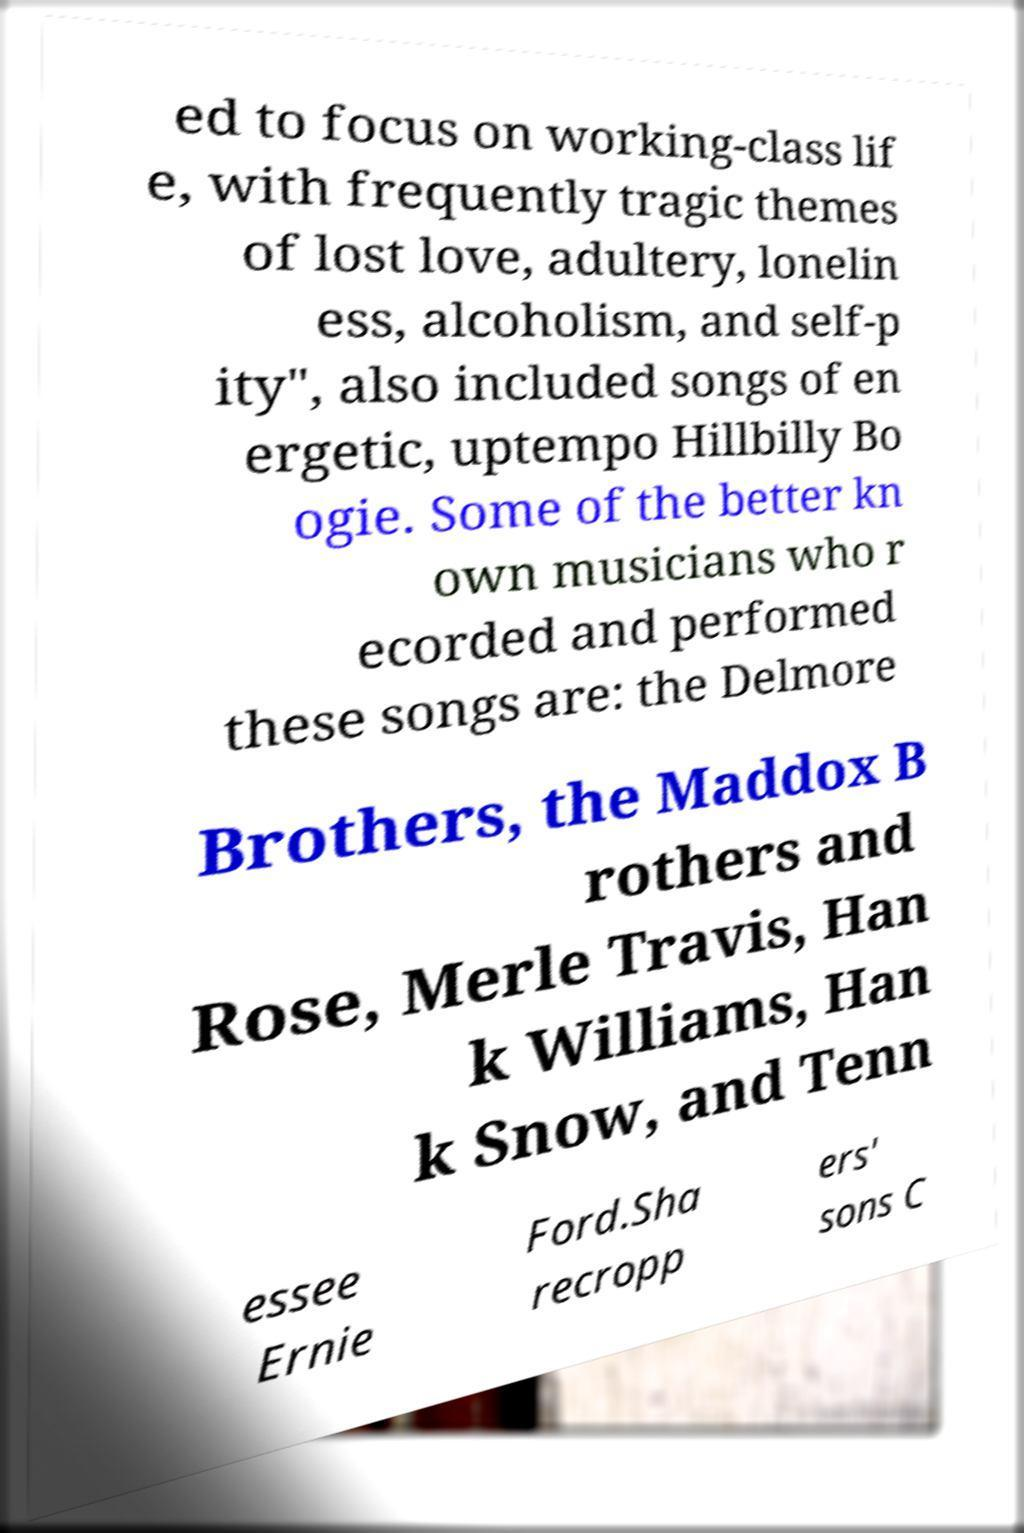What messages or text are displayed in this image? I need them in a readable, typed format. ed to focus on working-class lif e, with frequently tragic themes of lost love, adultery, lonelin ess, alcoholism, and self-p ity", also included songs of en ergetic, uptempo Hillbilly Bo ogie. Some of the better kn own musicians who r ecorded and performed these songs are: the Delmore Brothers, the Maddox B rothers and Rose, Merle Travis, Han k Williams, Han k Snow, and Tenn essee Ernie Ford.Sha recropp ers' sons C 